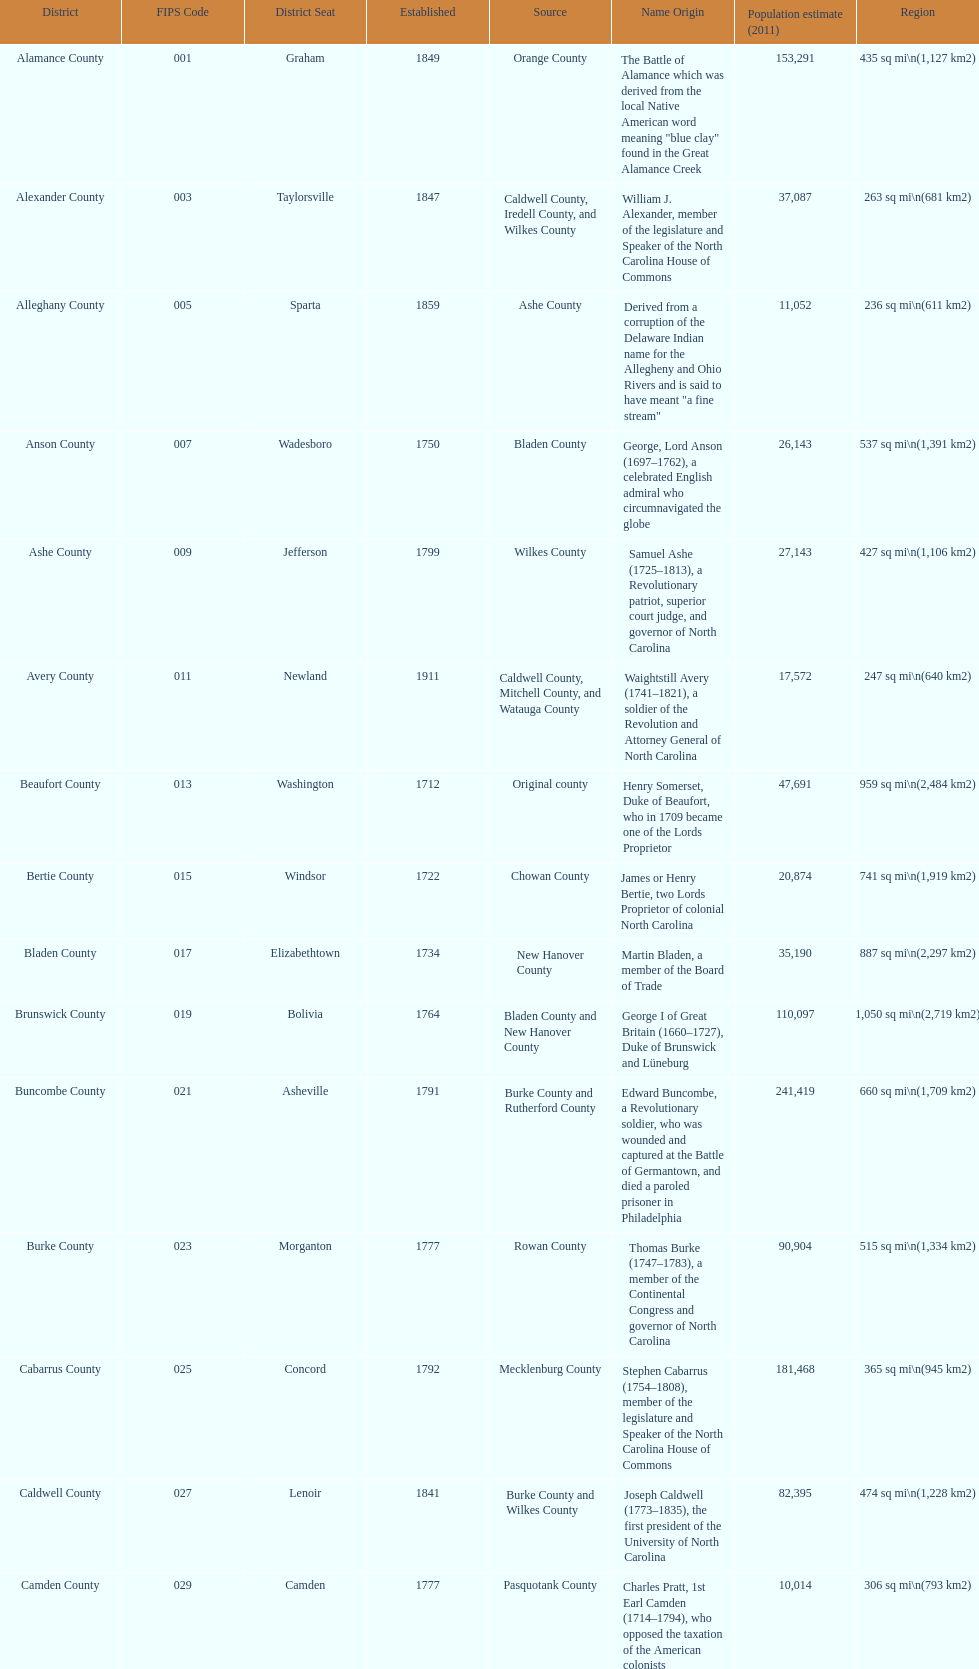Other than mecklenburg which county has the largest population? Wake County. 